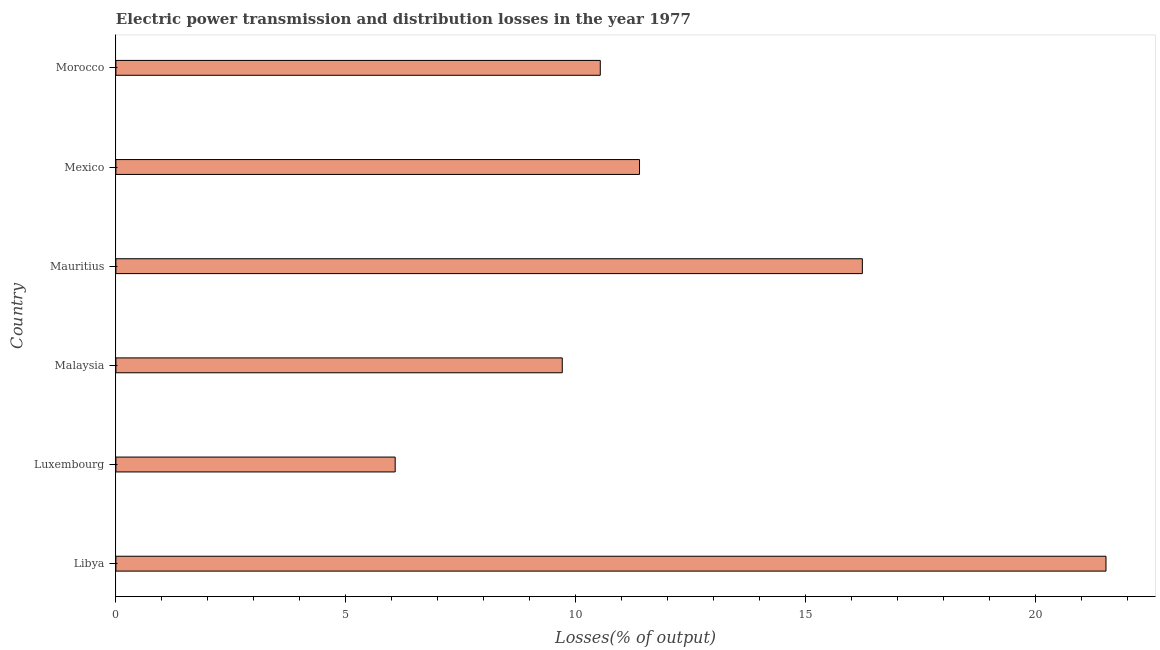Does the graph contain any zero values?
Provide a succinct answer. No. What is the title of the graph?
Your answer should be compact. Electric power transmission and distribution losses in the year 1977. What is the label or title of the X-axis?
Ensure brevity in your answer.  Losses(% of output). What is the label or title of the Y-axis?
Give a very brief answer. Country. What is the electric power transmission and distribution losses in Mauritius?
Your answer should be very brief. 16.23. Across all countries, what is the maximum electric power transmission and distribution losses?
Make the answer very short. 21.53. Across all countries, what is the minimum electric power transmission and distribution losses?
Offer a terse response. 6.07. In which country was the electric power transmission and distribution losses maximum?
Provide a short and direct response. Libya. In which country was the electric power transmission and distribution losses minimum?
Provide a succinct answer. Luxembourg. What is the sum of the electric power transmission and distribution losses?
Offer a very short reply. 75.47. What is the difference between the electric power transmission and distribution losses in Mexico and Morocco?
Your answer should be compact. 0.85. What is the average electric power transmission and distribution losses per country?
Make the answer very short. 12.58. What is the median electric power transmission and distribution losses?
Provide a succinct answer. 10.96. In how many countries, is the electric power transmission and distribution losses greater than 6 %?
Make the answer very short. 6. What is the ratio of the electric power transmission and distribution losses in Luxembourg to that in Mexico?
Give a very brief answer. 0.53. What is the difference between the highest and the second highest electric power transmission and distribution losses?
Your response must be concise. 5.3. What is the difference between the highest and the lowest electric power transmission and distribution losses?
Offer a terse response. 15.46. How many bars are there?
Offer a very short reply. 6. How many countries are there in the graph?
Make the answer very short. 6. What is the difference between two consecutive major ticks on the X-axis?
Your answer should be very brief. 5. Are the values on the major ticks of X-axis written in scientific E-notation?
Give a very brief answer. No. What is the Losses(% of output) of Libya?
Offer a terse response. 21.53. What is the Losses(% of output) in Luxembourg?
Offer a terse response. 6.07. What is the Losses(% of output) of Malaysia?
Your response must be concise. 9.71. What is the Losses(% of output) in Mauritius?
Provide a short and direct response. 16.23. What is the Losses(% of output) in Mexico?
Offer a terse response. 11.39. What is the Losses(% of output) in Morocco?
Provide a succinct answer. 10.53. What is the difference between the Losses(% of output) in Libya and Luxembourg?
Your answer should be compact. 15.46. What is the difference between the Losses(% of output) in Libya and Malaysia?
Offer a terse response. 11.82. What is the difference between the Losses(% of output) in Libya and Mauritius?
Ensure brevity in your answer.  5.3. What is the difference between the Losses(% of output) in Libya and Mexico?
Provide a succinct answer. 10.14. What is the difference between the Losses(% of output) in Libya and Morocco?
Give a very brief answer. 11. What is the difference between the Losses(% of output) in Luxembourg and Malaysia?
Give a very brief answer. -3.63. What is the difference between the Losses(% of output) in Luxembourg and Mauritius?
Your answer should be very brief. -10.16. What is the difference between the Losses(% of output) in Luxembourg and Mexico?
Provide a short and direct response. -5.31. What is the difference between the Losses(% of output) in Luxembourg and Morocco?
Offer a very short reply. -4.46. What is the difference between the Losses(% of output) in Malaysia and Mauritius?
Your answer should be compact. -6.53. What is the difference between the Losses(% of output) in Malaysia and Mexico?
Your response must be concise. -1.68. What is the difference between the Losses(% of output) in Malaysia and Morocco?
Provide a succinct answer. -0.83. What is the difference between the Losses(% of output) in Mauritius and Mexico?
Your response must be concise. 4.85. What is the difference between the Losses(% of output) in Mauritius and Morocco?
Provide a succinct answer. 5.7. What is the difference between the Losses(% of output) in Mexico and Morocco?
Your answer should be compact. 0.85. What is the ratio of the Losses(% of output) in Libya to that in Luxembourg?
Give a very brief answer. 3.54. What is the ratio of the Losses(% of output) in Libya to that in Malaysia?
Provide a succinct answer. 2.22. What is the ratio of the Losses(% of output) in Libya to that in Mauritius?
Give a very brief answer. 1.33. What is the ratio of the Losses(% of output) in Libya to that in Mexico?
Provide a succinct answer. 1.89. What is the ratio of the Losses(% of output) in Libya to that in Morocco?
Offer a very short reply. 2.04. What is the ratio of the Losses(% of output) in Luxembourg to that in Malaysia?
Your answer should be very brief. 0.63. What is the ratio of the Losses(% of output) in Luxembourg to that in Mauritius?
Keep it short and to the point. 0.37. What is the ratio of the Losses(% of output) in Luxembourg to that in Mexico?
Offer a very short reply. 0.53. What is the ratio of the Losses(% of output) in Luxembourg to that in Morocco?
Your answer should be compact. 0.58. What is the ratio of the Losses(% of output) in Malaysia to that in Mauritius?
Your response must be concise. 0.6. What is the ratio of the Losses(% of output) in Malaysia to that in Mexico?
Offer a terse response. 0.85. What is the ratio of the Losses(% of output) in Malaysia to that in Morocco?
Ensure brevity in your answer.  0.92. What is the ratio of the Losses(% of output) in Mauritius to that in Mexico?
Make the answer very short. 1.43. What is the ratio of the Losses(% of output) in Mauritius to that in Morocco?
Give a very brief answer. 1.54. What is the ratio of the Losses(% of output) in Mexico to that in Morocco?
Make the answer very short. 1.08. 